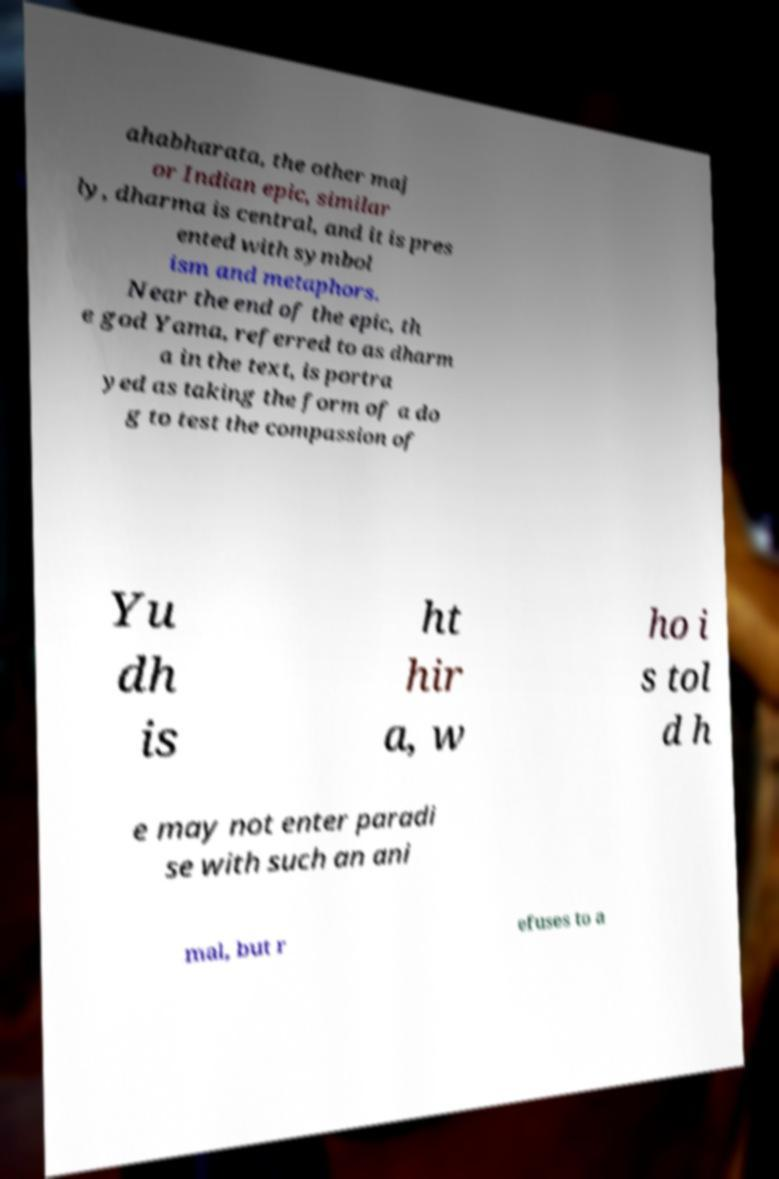What messages or text are displayed in this image? I need them in a readable, typed format. ahabharata, the other maj or Indian epic, similar ly, dharma is central, and it is pres ented with symbol ism and metaphors. Near the end of the epic, th e god Yama, referred to as dharm a in the text, is portra yed as taking the form of a do g to test the compassion of Yu dh is ht hir a, w ho i s tol d h e may not enter paradi se with such an ani mal, but r efuses to a 